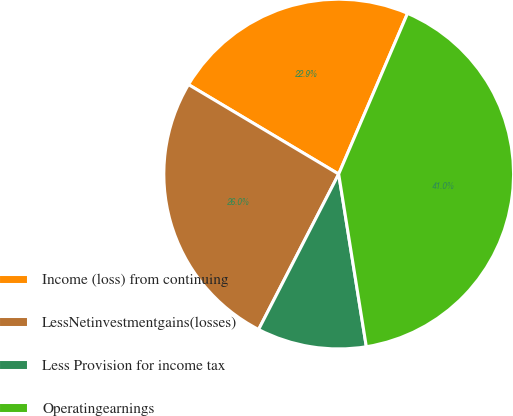<chart> <loc_0><loc_0><loc_500><loc_500><pie_chart><fcel>Income (loss) from continuing<fcel>LessNetinvestmentgains(losses)<fcel>Less Provision for income tax<fcel>Operatingearnings<nl><fcel>22.89%<fcel>25.98%<fcel>10.1%<fcel>41.03%<nl></chart> 